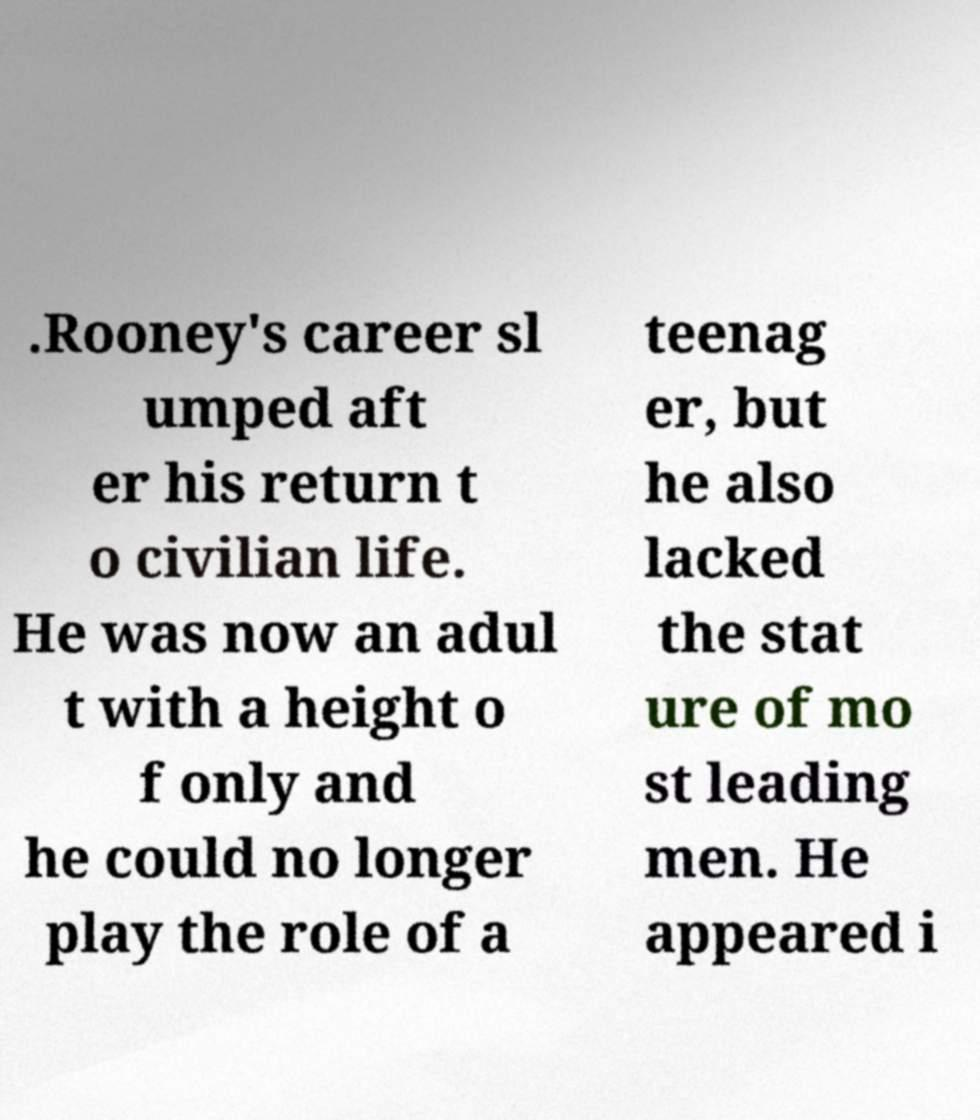Please identify and transcribe the text found in this image. .Rooney's career sl umped aft er his return t o civilian life. He was now an adul t with a height o f only and he could no longer play the role of a teenag er, but he also lacked the stat ure of mo st leading men. He appeared i 